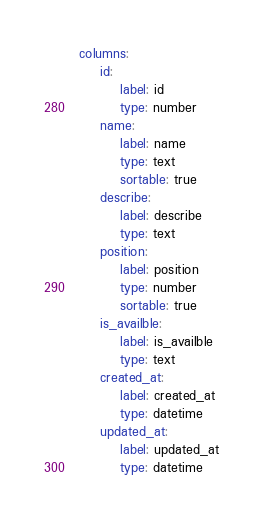Convert code to text. <code><loc_0><loc_0><loc_500><loc_500><_YAML_>columns:
    id:
        label: id
        type: number
    name:
        label: name
        type: text
        sortable: true
    describe:
        label: describe
        type: text
    position:
        label: position
        type: number
        sortable: true
    is_availble:
        label: is_availble
        type: text
    created_at:
        label: created_at
        type: datetime
    updated_at:
        label: updated_at
        type: datetime
</code> 